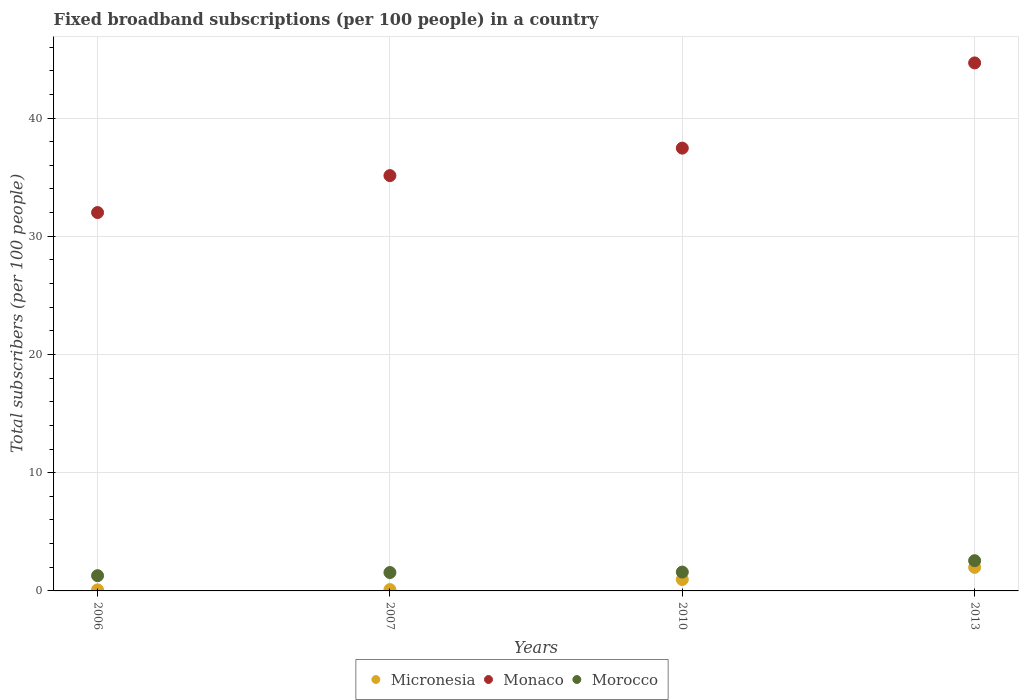What is the number of broadband subscriptions in Micronesia in 2006?
Offer a terse response. 0.09. Across all years, what is the maximum number of broadband subscriptions in Micronesia?
Your answer should be very brief. 1.99. Across all years, what is the minimum number of broadband subscriptions in Monaco?
Your answer should be very brief. 32.01. In which year was the number of broadband subscriptions in Morocco maximum?
Your answer should be compact. 2013. What is the total number of broadband subscriptions in Micronesia in the graph?
Offer a very short reply. 3.16. What is the difference between the number of broadband subscriptions in Micronesia in 2006 and that in 2007?
Keep it short and to the point. -0.02. What is the difference between the number of broadband subscriptions in Morocco in 2013 and the number of broadband subscriptions in Monaco in 2007?
Offer a terse response. -32.57. What is the average number of broadband subscriptions in Micronesia per year?
Ensure brevity in your answer.  0.79. In the year 2013, what is the difference between the number of broadband subscriptions in Micronesia and number of broadband subscriptions in Monaco?
Provide a short and direct response. -42.67. What is the ratio of the number of broadband subscriptions in Micronesia in 2007 to that in 2013?
Make the answer very short. 0.06. Is the number of broadband subscriptions in Micronesia in 2010 less than that in 2013?
Give a very brief answer. Yes. Is the difference between the number of broadband subscriptions in Micronesia in 2007 and 2013 greater than the difference between the number of broadband subscriptions in Monaco in 2007 and 2013?
Your answer should be compact. Yes. What is the difference between the highest and the second highest number of broadband subscriptions in Monaco?
Your answer should be compact. 7.21. What is the difference between the highest and the lowest number of broadband subscriptions in Morocco?
Make the answer very short. 1.27. Is the sum of the number of broadband subscriptions in Micronesia in 2007 and 2010 greater than the maximum number of broadband subscriptions in Monaco across all years?
Provide a succinct answer. No. Does the number of broadband subscriptions in Monaco monotonically increase over the years?
Your answer should be compact. Yes. Is the number of broadband subscriptions in Monaco strictly greater than the number of broadband subscriptions in Micronesia over the years?
Offer a terse response. Yes. Is the number of broadband subscriptions in Morocco strictly less than the number of broadband subscriptions in Monaco over the years?
Offer a very short reply. Yes. How many dotlines are there?
Ensure brevity in your answer.  3. What is the difference between two consecutive major ticks on the Y-axis?
Ensure brevity in your answer.  10. Does the graph contain any zero values?
Keep it short and to the point. No. Where does the legend appear in the graph?
Provide a short and direct response. Bottom center. How are the legend labels stacked?
Offer a very short reply. Horizontal. What is the title of the graph?
Offer a terse response. Fixed broadband subscriptions (per 100 people) in a country. Does "Other small states" appear as one of the legend labels in the graph?
Your response must be concise. No. What is the label or title of the X-axis?
Provide a succinct answer. Years. What is the label or title of the Y-axis?
Your response must be concise. Total subscribers (per 100 people). What is the Total subscribers (per 100 people) of Micronesia in 2006?
Ensure brevity in your answer.  0.09. What is the Total subscribers (per 100 people) of Monaco in 2006?
Your response must be concise. 32.01. What is the Total subscribers (per 100 people) of Morocco in 2006?
Your response must be concise. 1.29. What is the Total subscribers (per 100 people) in Micronesia in 2007?
Your answer should be compact. 0.11. What is the Total subscribers (per 100 people) in Monaco in 2007?
Provide a short and direct response. 35.13. What is the Total subscribers (per 100 people) in Morocco in 2007?
Offer a very short reply. 1.56. What is the Total subscribers (per 100 people) in Micronesia in 2010?
Your answer should be compact. 0.96. What is the Total subscribers (per 100 people) in Monaco in 2010?
Ensure brevity in your answer.  37.45. What is the Total subscribers (per 100 people) of Morocco in 2010?
Give a very brief answer. 1.59. What is the Total subscribers (per 100 people) of Micronesia in 2013?
Your answer should be very brief. 1.99. What is the Total subscribers (per 100 people) in Monaco in 2013?
Your answer should be compact. 44.66. What is the Total subscribers (per 100 people) in Morocco in 2013?
Make the answer very short. 2.56. Across all years, what is the maximum Total subscribers (per 100 people) in Micronesia?
Give a very brief answer. 1.99. Across all years, what is the maximum Total subscribers (per 100 people) in Monaco?
Provide a succinct answer. 44.66. Across all years, what is the maximum Total subscribers (per 100 people) of Morocco?
Provide a succinct answer. 2.56. Across all years, what is the minimum Total subscribers (per 100 people) of Micronesia?
Your answer should be very brief. 0.09. Across all years, what is the minimum Total subscribers (per 100 people) of Monaco?
Give a very brief answer. 32.01. Across all years, what is the minimum Total subscribers (per 100 people) in Morocco?
Give a very brief answer. 1.29. What is the total Total subscribers (per 100 people) in Micronesia in the graph?
Offer a very short reply. 3.16. What is the total Total subscribers (per 100 people) of Monaco in the graph?
Provide a short and direct response. 149.25. What is the total Total subscribers (per 100 people) in Morocco in the graph?
Offer a very short reply. 7. What is the difference between the Total subscribers (per 100 people) of Micronesia in 2006 and that in 2007?
Keep it short and to the point. -0.02. What is the difference between the Total subscribers (per 100 people) in Monaco in 2006 and that in 2007?
Provide a short and direct response. -3.12. What is the difference between the Total subscribers (per 100 people) in Morocco in 2006 and that in 2007?
Provide a short and direct response. -0.27. What is the difference between the Total subscribers (per 100 people) of Micronesia in 2006 and that in 2010?
Give a very brief answer. -0.87. What is the difference between the Total subscribers (per 100 people) in Monaco in 2006 and that in 2010?
Your answer should be compact. -5.45. What is the difference between the Total subscribers (per 100 people) in Morocco in 2006 and that in 2010?
Offer a very short reply. -0.31. What is the difference between the Total subscribers (per 100 people) of Micronesia in 2006 and that in 2013?
Provide a succinct answer. -1.9. What is the difference between the Total subscribers (per 100 people) of Monaco in 2006 and that in 2013?
Your answer should be compact. -12.66. What is the difference between the Total subscribers (per 100 people) in Morocco in 2006 and that in 2013?
Your answer should be compact. -1.27. What is the difference between the Total subscribers (per 100 people) of Micronesia in 2007 and that in 2010?
Ensure brevity in your answer.  -0.85. What is the difference between the Total subscribers (per 100 people) of Monaco in 2007 and that in 2010?
Provide a short and direct response. -2.32. What is the difference between the Total subscribers (per 100 people) in Morocco in 2007 and that in 2010?
Your answer should be very brief. -0.04. What is the difference between the Total subscribers (per 100 people) of Micronesia in 2007 and that in 2013?
Offer a very short reply. -1.88. What is the difference between the Total subscribers (per 100 people) of Monaco in 2007 and that in 2013?
Your answer should be compact. -9.53. What is the difference between the Total subscribers (per 100 people) of Morocco in 2007 and that in 2013?
Make the answer very short. -1. What is the difference between the Total subscribers (per 100 people) of Micronesia in 2010 and that in 2013?
Your response must be concise. -1.03. What is the difference between the Total subscribers (per 100 people) in Monaco in 2010 and that in 2013?
Make the answer very short. -7.21. What is the difference between the Total subscribers (per 100 people) of Morocco in 2010 and that in 2013?
Your response must be concise. -0.96. What is the difference between the Total subscribers (per 100 people) of Micronesia in 2006 and the Total subscribers (per 100 people) of Monaco in 2007?
Offer a terse response. -35.04. What is the difference between the Total subscribers (per 100 people) of Micronesia in 2006 and the Total subscribers (per 100 people) of Morocco in 2007?
Offer a very short reply. -1.47. What is the difference between the Total subscribers (per 100 people) in Monaco in 2006 and the Total subscribers (per 100 people) in Morocco in 2007?
Your answer should be compact. 30.45. What is the difference between the Total subscribers (per 100 people) in Micronesia in 2006 and the Total subscribers (per 100 people) in Monaco in 2010?
Your answer should be very brief. -37.36. What is the difference between the Total subscribers (per 100 people) of Micronesia in 2006 and the Total subscribers (per 100 people) of Morocco in 2010?
Keep it short and to the point. -1.5. What is the difference between the Total subscribers (per 100 people) in Monaco in 2006 and the Total subscribers (per 100 people) in Morocco in 2010?
Make the answer very short. 30.41. What is the difference between the Total subscribers (per 100 people) of Micronesia in 2006 and the Total subscribers (per 100 people) of Monaco in 2013?
Offer a terse response. -44.57. What is the difference between the Total subscribers (per 100 people) in Micronesia in 2006 and the Total subscribers (per 100 people) in Morocco in 2013?
Provide a succinct answer. -2.47. What is the difference between the Total subscribers (per 100 people) of Monaco in 2006 and the Total subscribers (per 100 people) of Morocco in 2013?
Provide a short and direct response. 29.45. What is the difference between the Total subscribers (per 100 people) in Micronesia in 2007 and the Total subscribers (per 100 people) in Monaco in 2010?
Provide a succinct answer. -37.34. What is the difference between the Total subscribers (per 100 people) in Micronesia in 2007 and the Total subscribers (per 100 people) in Morocco in 2010?
Keep it short and to the point. -1.48. What is the difference between the Total subscribers (per 100 people) in Monaco in 2007 and the Total subscribers (per 100 people) in Morocco in 2010?
Give a very brief answer. 33.54. What is the difference between the Total subscribers (per 100 people) in Micronesia in 2007 and the Total subscribers (per 100 people) in Monaco in 2013?
Offer a very short reply. -44.55. What is the difference between the Total subscribers (per 100 people) of Micronesia in 2007 and the Total subscribers (per 100 people) of Morocco in 2013?
Offer a very short reply. -2.45. What is the difference between the Total subscribers (per 100 people) in Monaco in 2007 and the Total subscribers (per 100 people) in Morocco in 2013?
Offer a very short reply. 32.57. What is the difference between the Total subscribers (per 100 people) of Micronesia in 2010 and the Total subscribers (per 100 people) of Monaco in 2013?
Make the answer very short. -43.7. What is the difference between the Total subscribers (per 100 people) in Micronesia in 2010 and the Total subscribers (per 100 people) in Morocco in 2013?
Give a very brief answer. -1.59. What is the difference between the Total subscribers (per 100 people) in Monaco in 2010 and the Total subscribers (per 100 people) in Morocco in 2013?
Your answer should be compact. 34.9. What is the average Total subscribers (per 100 people) of Micronesia per year?
Give a very brief answer. 0.79. What is the average Total subscribers (per 100 people) of Monaco per year?
Provide a short and direct response. 37.31. What is the average Total subscribers (per 100 people) in Morocco per year?
Your response must be concise. 1.75. In the year 2006, what is the difference between the Total subscribers (per 100 people) of Micronesia and Total subscribers (per 100 people) of Monaco?
Give a very brief answer. -31.92. In the year 2006, what is the difference between the Total subscribers (per 100 people) in Micronesia and Total subscribers (per 100 people) in Morocco?
Offer a terse response. -1.2. In the year 2006, what is the difference between the Total subscribers (per 100 people) of Monaco and Total subscribers (per 100 people) of Morocco?
Ensure brevity in your answer.  30.72. In the year 2007, what is the difference between the Total subscribers (per 100 people) in Micronesia and Total subscribers (per 100 people) in Monaco?
Ensure brevity in your answer.  -35.02. In the year 2007, what is the difference between the Total subscribers (per 100 people) in Micronesia and Total subscribers (per 100 people) in Morocco?
Your response must be concise. -1.45. In the year 2007, what is the difference between the Total subscribers (per 100 people) in Monaco and Total subscribers (per 100 people) in Morocco?
Keep it short and to the point. 33.57. In the year 2010, what is the difference between the Total subscribers (per 100 people) in Micronesia and Total subscribers (per 100 people) in Monaco?
Your answer should be compact. -36.49. In the year 2010, what is the difference between the Total subscribers (per 100 people) in Micronesia and Total subscribers (per 100 people) in Morocco?
Your response must be concise. -0.63. In the year 2010, what is the difference between the Total subscribers (per 100 people) of Monaco and Total subscribers (per 100 people) of Morocco?
Give a very brief answer. 35.86. In the year 2013, what is the difference between the Total subscribers (per 100 people) in Micronesia and Total subscribers (per 100 people) in Monaco?
Give a very brief answer. -42.67. In the year 2013, what is the difference between the Total subscribers (per 100 people) in Micronesia and Total subscribers (per 100 people) in Morocco?
Offer a very short reply. -0.56. In the year 2013, what is the difference between the Total subscribers (per 100 people) in Monaco and Total subscribers (per 100 people) in Morocco?
Make the answer very short. 42.1. What is the ratio of the Total subscribers (per 100 people) in Micronesia in 2006 to that in 2007?
Your answer should be very brief. 0.81. What is the ratio of the Total subscribers (per 100 people) of Monaco in 2006 to that in 2007?
Offer a very short reply. 0.91. What is the ratio of the Total subscribers (per 100 people) in Morocco in 2006 to that in 2007?
Offer a very short reply. 0.83. What is the ratio of the Total subscribers (per 100 people) of Micronesia in 2006 to that in 2010?
Make the answer very short. 0.09. What is the ratio of the Total subscribers (per 100 people) of Monaco in 2006 to that in 2010?
Ensure brevity in your answer.  0.85. What is the ratio of the Total subscribers (per 100 people) in Morocco in 2006 to that in 2010?
Provide a succinct answer. 0.81. What is the ratio of the Total subscribers (per 100 people) of Micronesia in 2006 to that in 2013?
Ensure brevity in your answer.  0.05. What is the ratio of the Total subscribers (per 100 people) of Monaco in 2006 to that in 2013?
Your response must be concise. 0.72. What is the ratio of the Total subscribers (per 100 people) of Morocco in 2006 to that in 2013?
Offer a very short reply. 0.5. What is the ratio of the Total subscribers (per 100 people) in Micronesia in 2007 to that in 2010?
Offer a terse response. 0.11. What is the ratio of the Total subscribers (per 100 people) in Monaco in 2007 to that in 2010?
Keep it short and to the point. 0.94. What is the ratio of the Total subscribers (per 100 people) in Morocco in 2007 to that in 2010?
Your answer should be very brief. 0.98. What is the ratio of the Total subscribers (per 100 people) of Micronesia in 2007 to that in 2013?
Your response must be concise. 0.06. What is the ratio of the Total subscribers (per 100 people) of Monaco in 2007 to that in 2013?
Provide a short and direct response. 0.79. What is the ratio of the Total subscribers (per 100 people) in Morocco in 2007 to that in 2013?
Your answer should be compact. 0.61. What is the ratio of the Total subscribers (per 100 people) of Micronesia in 2010 to that in 2013?
Your answer should be very brief. 0.48. What is the ratio of the Total subscribers (per 100 people) of Monaco in 2010 to that in 2013?
Ensure brevity in your answer.  0.84. What is the ratio of the Total subscribers (per 100 people) of Morocco in 2010 to that in 2013?
Offer a very short reply. 0.62. What is the difference between the highest and the second highest Total subscribers (per 100 people) of Micronesia?
Give a very brief answer. 1.03. What is the difference between the highest and the second highest Total subscribers (per 100 people) in Monaco?
Make the answer very short. 7.21. What is the difference between the highest and the second highest Total subscribers (per 100 people) of Morocco?
Your answer should be compact. 0.96. What is the difference between the highest and the lowest Total subscribers (per 100 people) of Micronesia?
Your answer should be very brief. 1.9. What is the difference between the highest and the lowest Total subscribers (per 100 people) in Monaco?
Keep it short and to the point. 12.66. What is the difference between the highest and the lowest Total subscribers (per 100 people) of Morocco?
Ensure brevity in your answer.  1.27. 